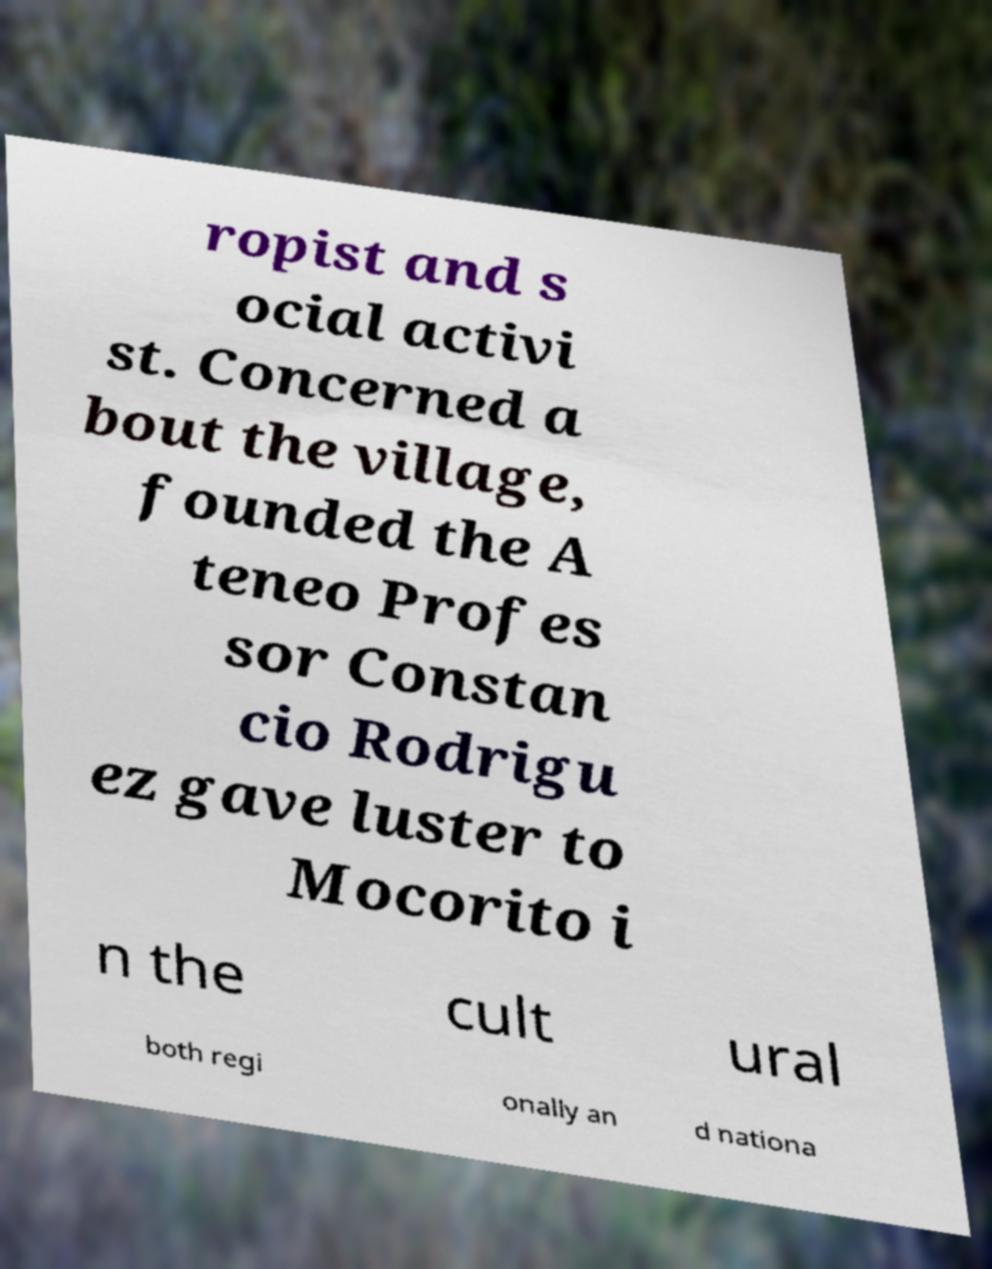Please read and relay the text visible in this image. What does it say? ropist and s ocial activi st. Concerned a bout the village, founded the A teneo Profes sor Constan cio Rodrigu ez gave luster to Mocorito i n the cult ural both regi onally an d nationa 